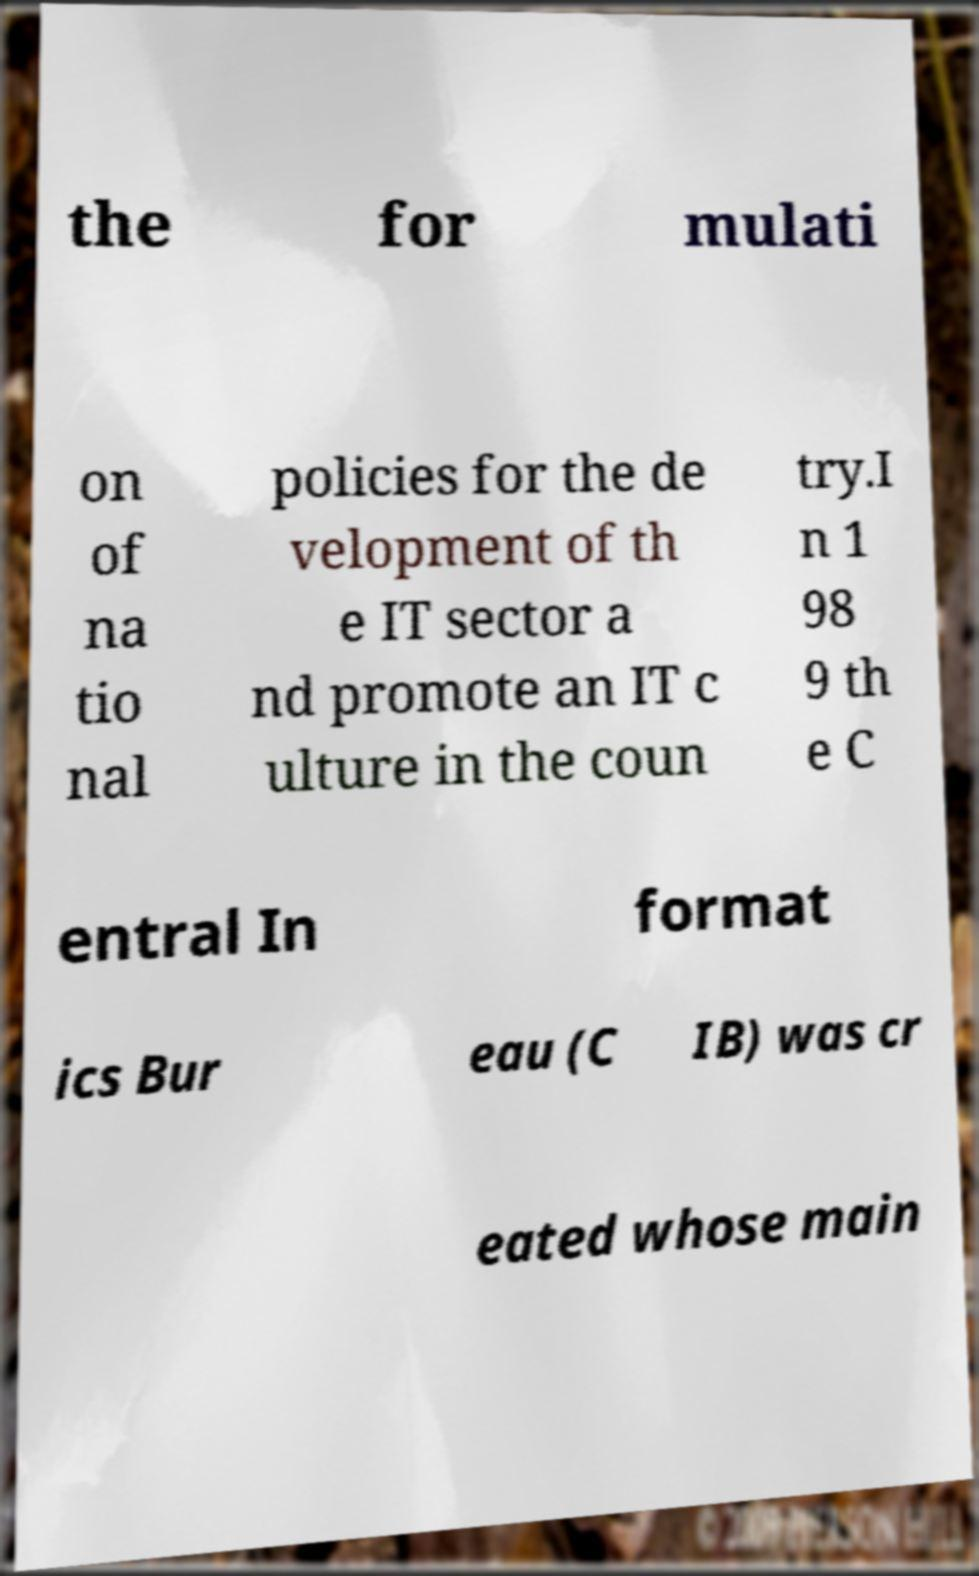For documentation purposes, I need the text within this image transcribed. Could you provide that? the for mulati on of na tio nal policies for the de velopment of th e IT sector a nd promote an IT c ulture in the coun try.I n 1 98 9 th e C entral In format ics Bur eau (C IB) was cr eated whose main 